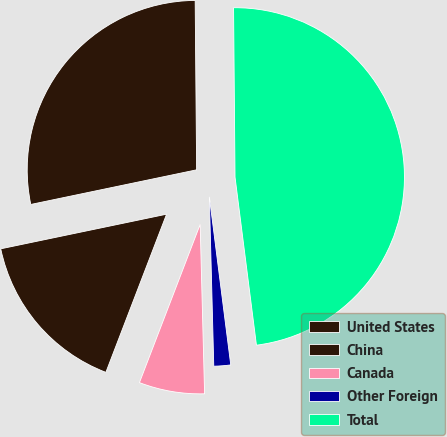<chart> <loc_0><loc_0><loc_500><loc_500><pie_chart><fcel>United States<fcel>China<fcel>Canada<fcel>Other Foreign<fcel>Total<nl><fcel>28.14%<fcel>15.89%<fcel>6.25%<fcel>1.6%<fcel>48.12%<nl></chart> 